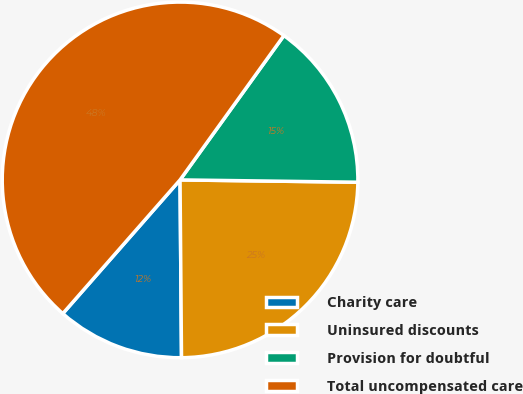Convert chart to OTSL. <chart><loc_0><loc_0><loc_500><loc_500><pie_chart><fcel>Charity care<fcel>Uninsured discounts<fcel>Provision for doubtful<fcel>Total uncompensated care<nl><fcel>11.59%<fcel>24.66%<fcel>15.28%<fcel>48.46%<nl></chart> 